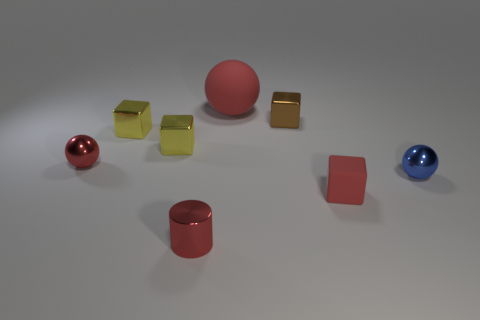How many other things are the same material as the red cylinder?
Your answer should be very brief. 5. What number of cyan things are either small shiny spheres or tiny objects?
Your answer should be very brief. 0. There is a red thing right of the big red ball; is it the same shape as the blue metallic object in front of the big object?
Give a very brief answer. No. Do the small cylinder and the metal block on the right side of the red cylinder have the same color?
Your answer should be very brief. No. There is a tiny metal ball to the left of the big rubber object; does it have the same color as the tiny metallic cylinder?
Provide a short and direct response. Yes. How many things are either big red matte balls or red things behind the small brown metal cube?
Ensure brevity in your answer.  1. What material is the tiny red thing that is left of the brown shiny thing and in front of the blue thing?
Make the answer very short. Metal. There is a red ball that is in front of the large red matte thing; what is it made of?
Your answer should be very brief. Metal. What is the color of the block that is made of the same material as the large ball?
Keep it short and to the point. Red. Is the shape of the blue metallic thing the same as the red rubber thing in front of the brown block?
Give a very brief answer. No. 